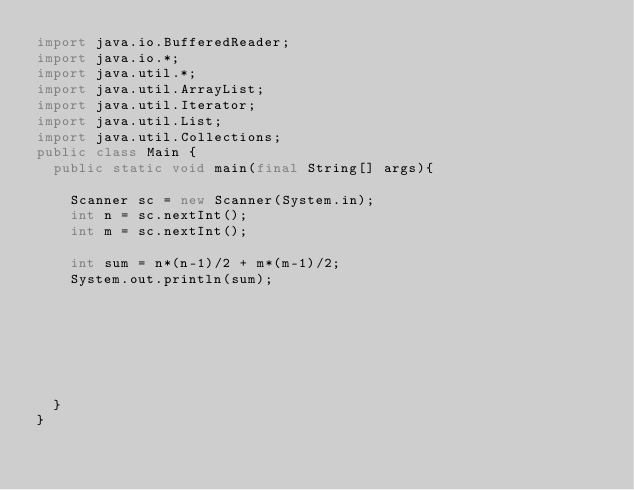Convert code to text. <code><loc_0><loc_0><loc_500><loc_500><_Java_>import java.io.BufferedReader;
import java.io.*;
import java.util.*;
import java.util.ArrayList;
import java.util.Iterator;
import java.util.List;
import java.util.Collections;
public class Main {
	public static void main(final String[] args){
    
    Scanner sc = new Scanner(System.in);
    int n = sc.nextInt();
    int m = sc.nextInt();

    int sum = n*(n-1)/2 + m*(m-1)/2;
    System.out.println(sum);




    
    
    
	}
}</code> 